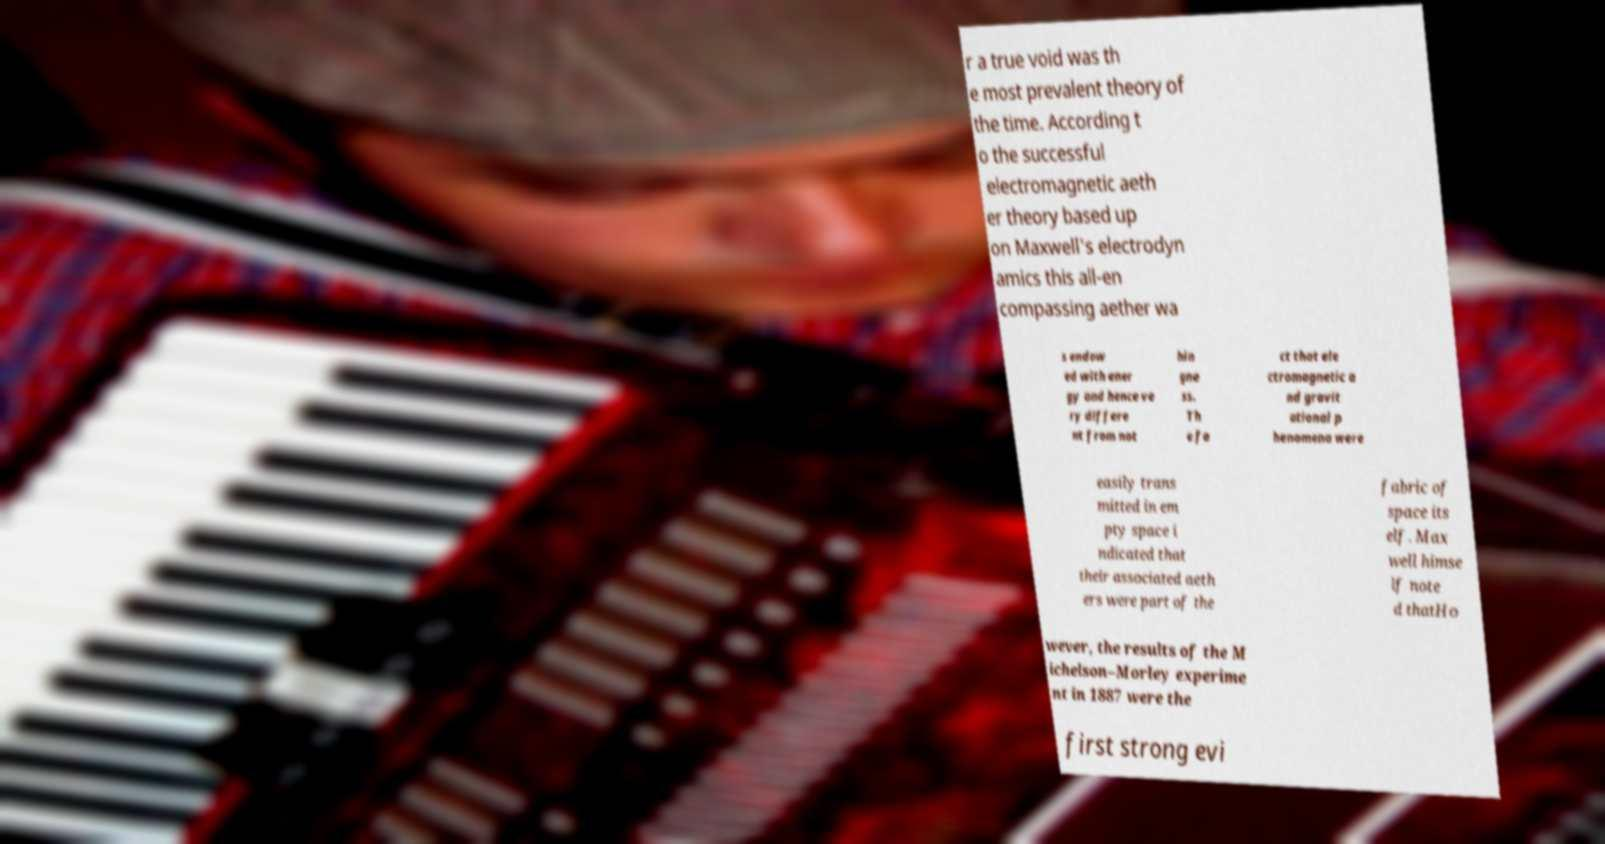There's text embedded in this image that I need extracted. Can you transcribe it verbatim? r a true void was th e most prevalent theory of the time. According t o the successful electromagnetic aeth er theory based up on Maxwell's electrodyn amics this all-en compassing aether wa s endow ed with ener gy and hence ve ry differe nt from not hin gne ss. Th e fa ct that ele ctromagnetic a nd gravit ational p henomena were easily trans mitted in em pty space i ndicated that their associated aeth ers were part of the fabric of space its elf. Max well himse lf note d thatHo wever, the results of the M ichelson–Morley experime nt in 1887 were the first strong evi 